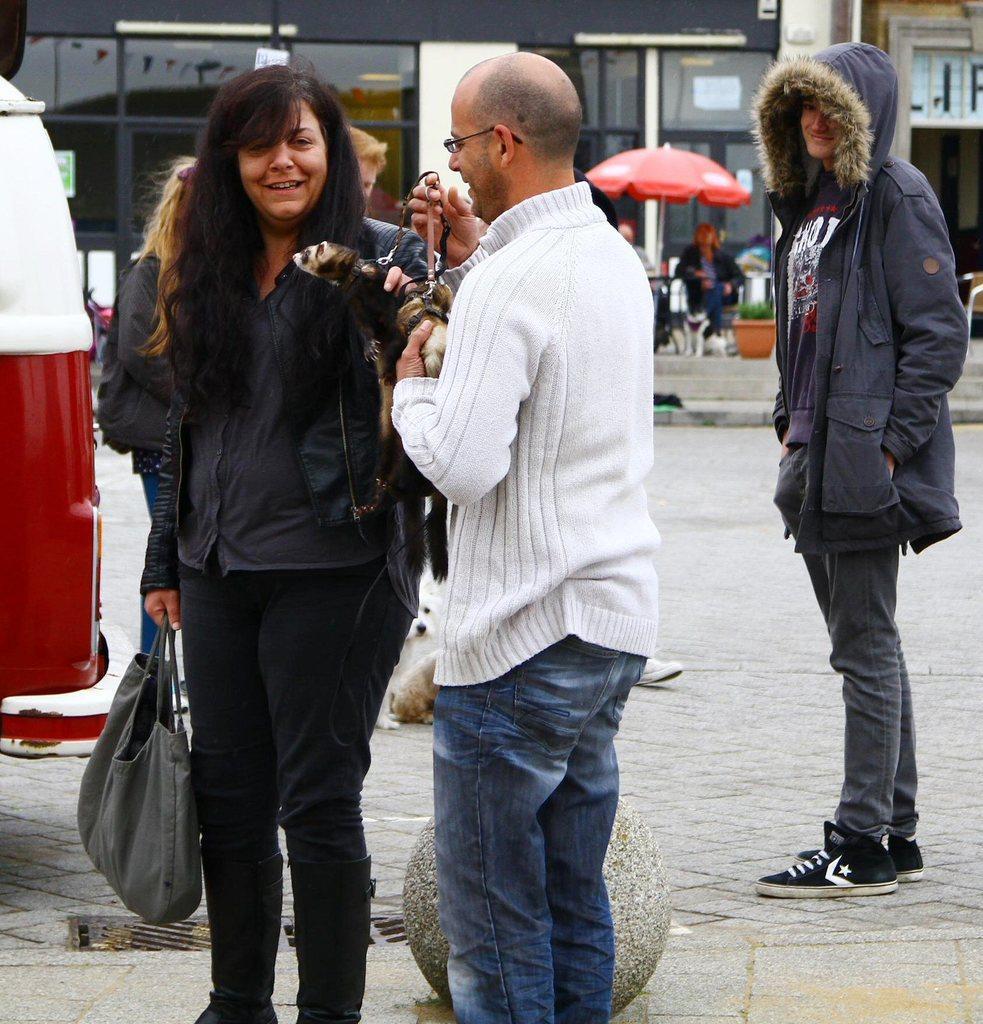Could you give a brief overview of what you see in this image? In this picture we can see man wearing a white color t-shirt, standing and holding the small dog in the hand. Beside there is a woman wearing a black color coat, looking and smiling. In the background there is a black color glass shop and red umbrella. 